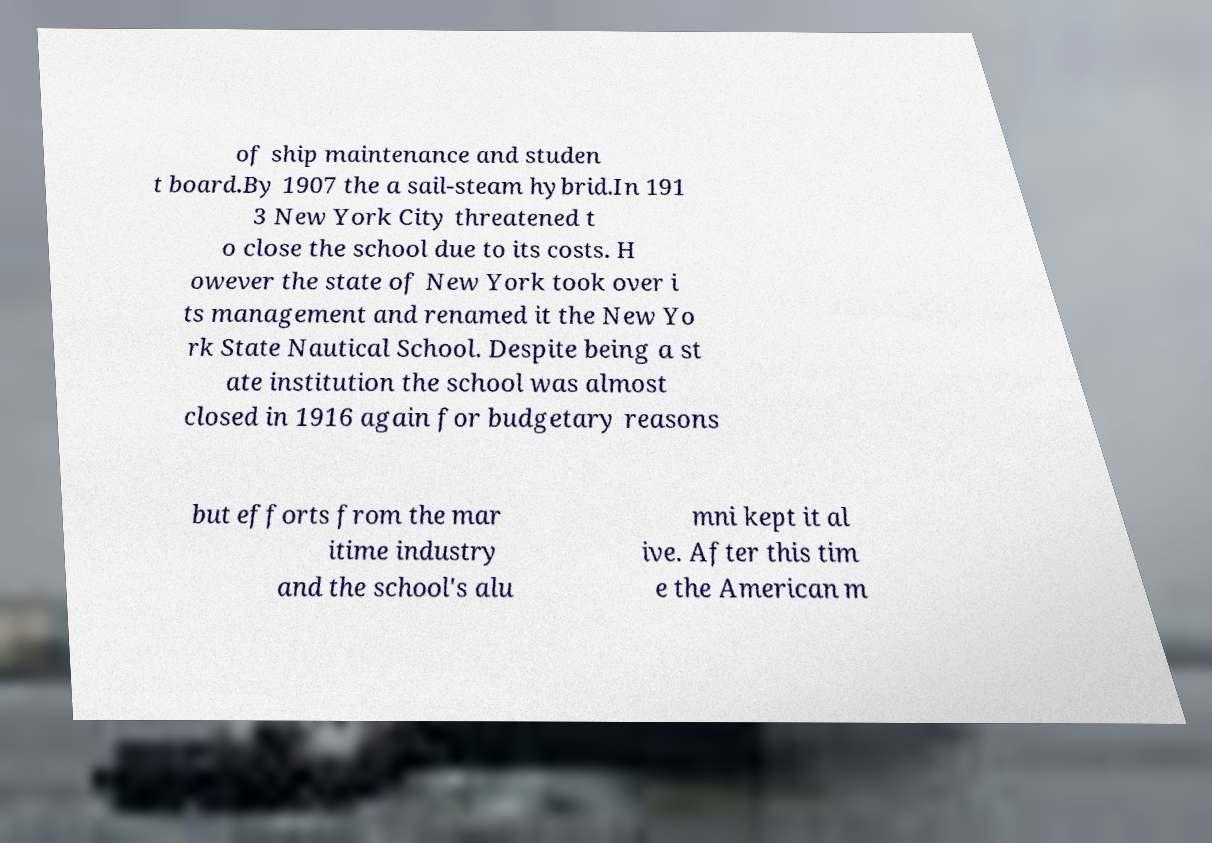Please identify and transcribe the text found in this image. of ship maintenance and studen t board.By 1907 the a sail-steam hybrid.In 191 3 New York City threatened t o close the school due to its costs. H owever the state of New York took over i ts management and renamed it the New Yo rk State Nautical School. Despite being a st ate institution the school was almost closed in 1916 again for budgetary reasons but efforts from the mar itime industry and the school's alu mni kept it al ive. After this tim e the American m 